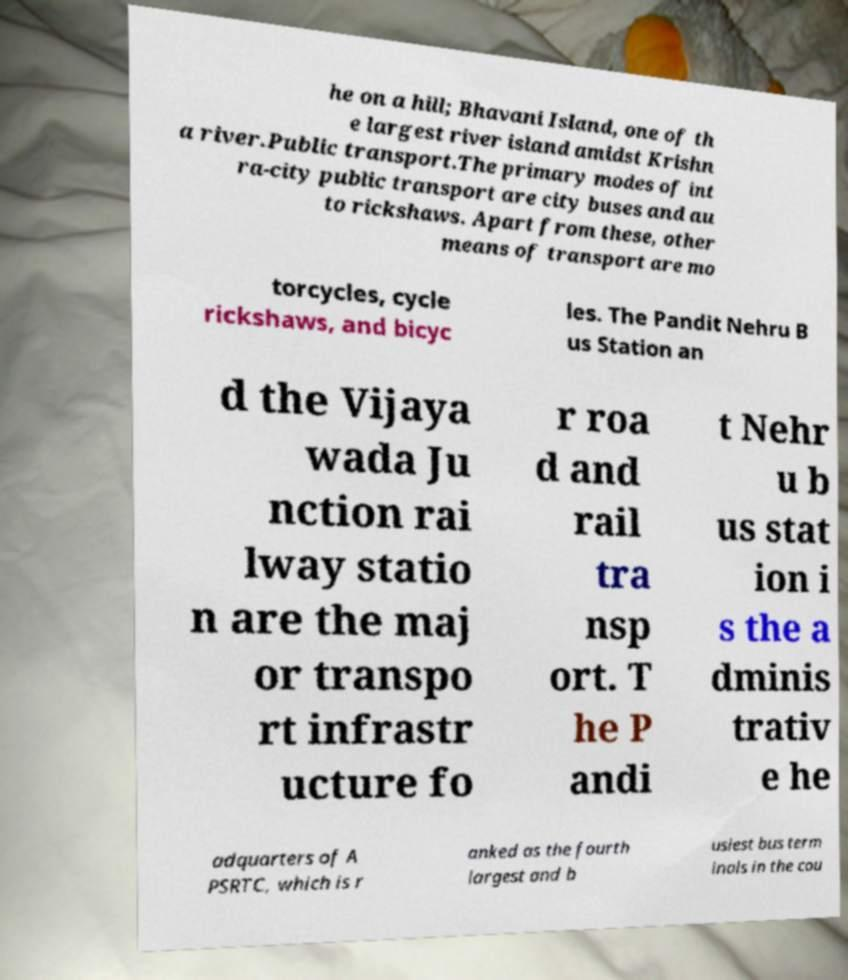Please identify and transcribe the text found in this image. he on a hill; Bhavani Island, one of th e largest river island amidst Krishn a river.Public transport.The primary modes of int ra-city public transport are city buses and au to rickshaws. Apart from these, other means of transport are mo torcycles, cycle rickshaws, and bicyc les. The Pandit Nehru B us Station an d the Vijaya wada Ju nction rai lway statio n are the maj or transpo rt infrastr ucture fo r roa d and rail tra nsp ort. T he P andi t Nehr u b us stat ion i s the a dminis trativ e he adquarters of A PSRTC, which is r anked as the fourth largest and b usiest bus term inals in the cou 